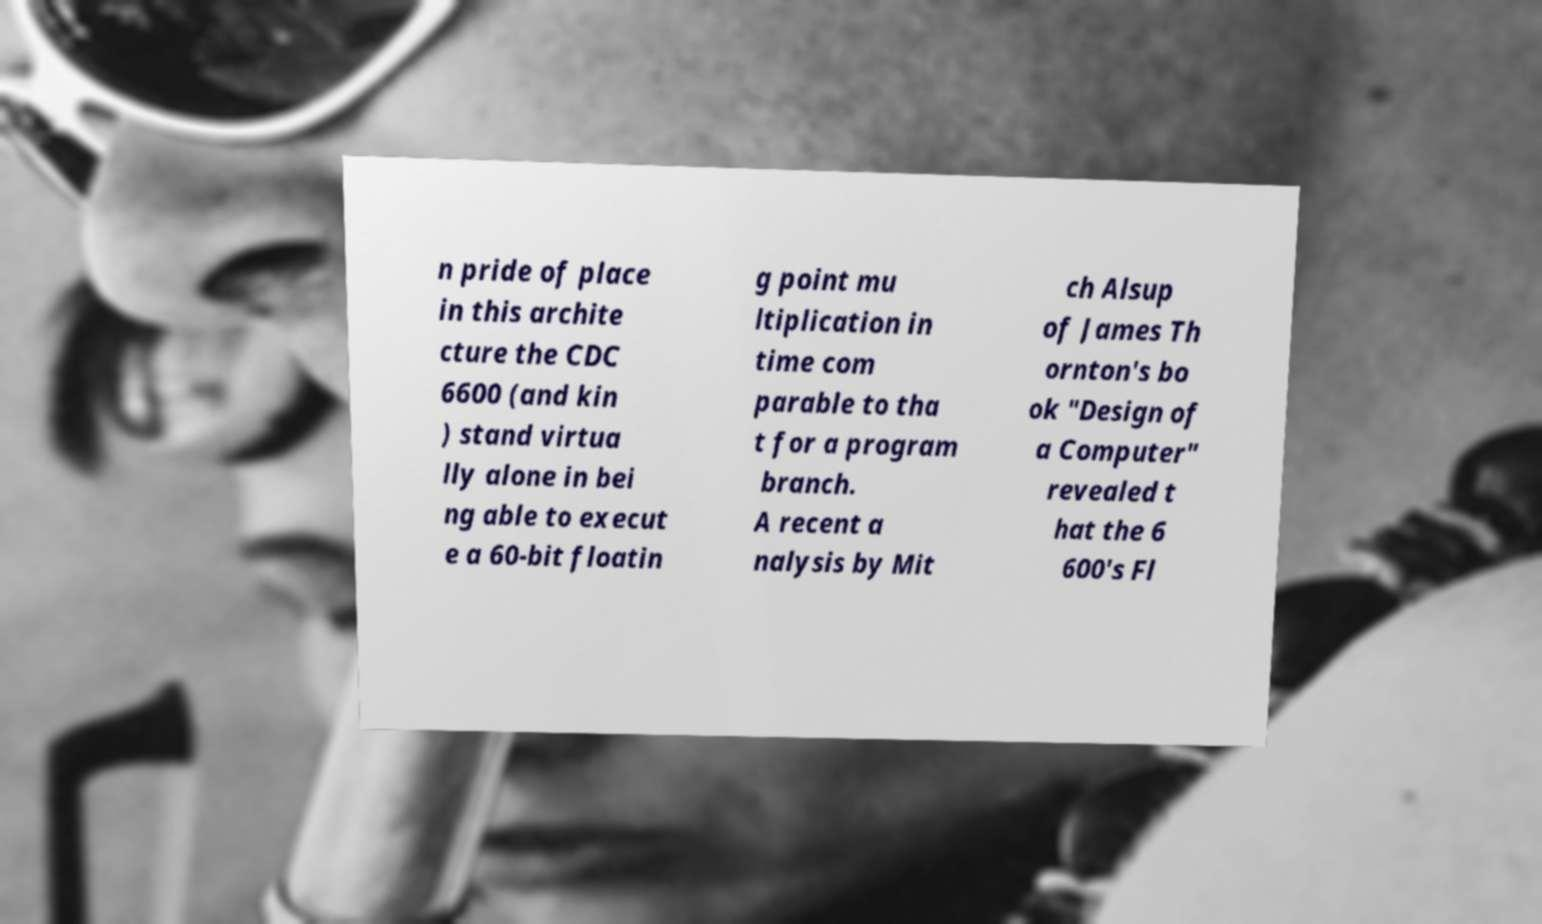Can you read and provide the text displayed in the image?This photo seems to have some interesting text. Can you extract and type it out for me? n pride of place in this archite cture the CDC 6600 (and kin ) stand virtua lly alone in bei ng able to execut e a 60-bit floatin g point mu ltiplication in time com parable to tha t for a program branch. A recent a nalysis by Mit ch Alsup of James Th ornton's bo ok "Design of a Computer" revealed t hat the 6 600's Fl 